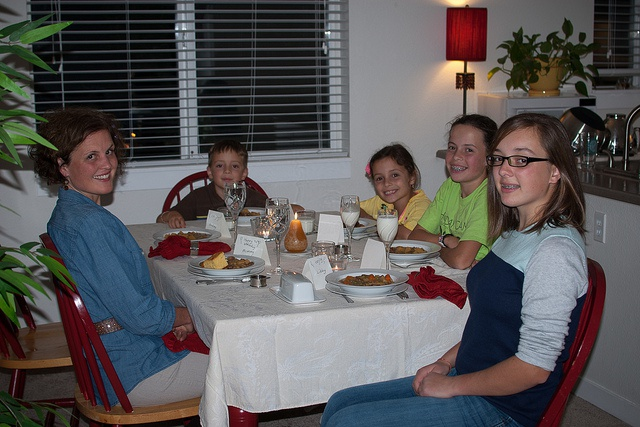Describe the objects in this image and their specific colors. I can see dining table in gray, darkgray, and maroon tones, people in gray, black, darkgray, and blue tones, people in gray, blue, black, and darkblue tones, potted plant in gray, black, and darkgreen tones, and people in gray, olive, and black tones in this image. 